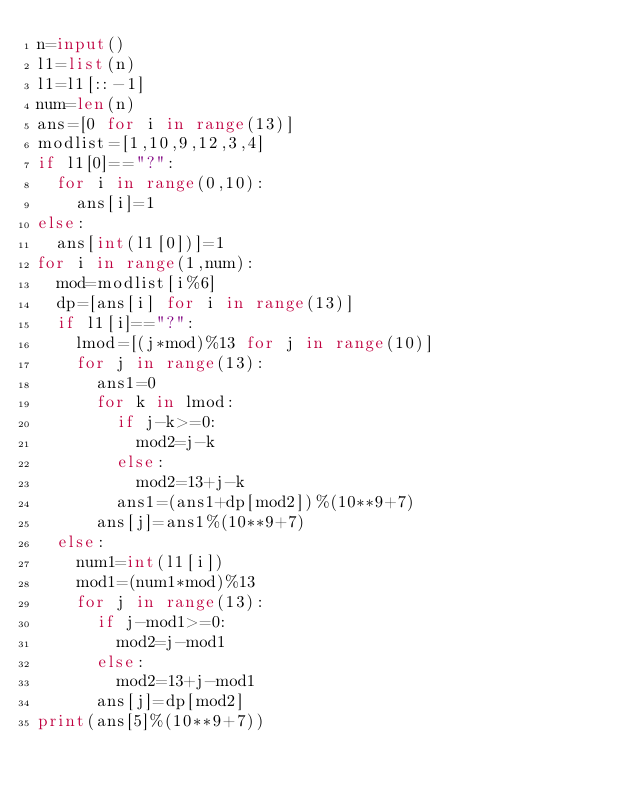<code> <loc_0><loc_0><loc_500><loc_500><_Python_>n=input()
l1=list(n)
l1=l1[::-1]
num=len(n)
ans=[0 for i in range(13)]
modlist=[1,10,9,12,3,4]
if l1[0]=="?":
  for i in range(0,10):
    ans[i]=1
else:
  ans[int(l1[0])]=1
for i in range(1,num):
  mod=modlist[i%6]
  dp=[ans[i] for i in range(13)]
  if l1[i]=="?":
    lmod=[(j*mod)%13 for j in range(10)]
    for j in range(13):
      ans1=0
      for k in lmod:
        if j-k>=0:
          mod2=j-k
        else:
          mod2=13+j-k
        ans1=(ans1+dp[mod2])%(10**9+7)
      ans[j]=ans1%(10**9+7)
  else:
    num1=int(l1[i])
    mod1=(num1*mod)%13
    for j in range(13):
      if j-mod1>=0:
        mod2=j-mod1
      else:
        mod2=13+j-mod1
      ans[j]=dp[mod2]
print(ans[5]%(10**9+7))
</code> 